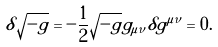Convert formula to latex. <formula><loc_0><loc_0><loc_500><loc_500>\delta \sqrt { - g } = - \frac { 1 } { 2 } \sqrt { - g } g _ { \mu \nu } \delta g ^ { \mu \nu } = 0 .</formula> 